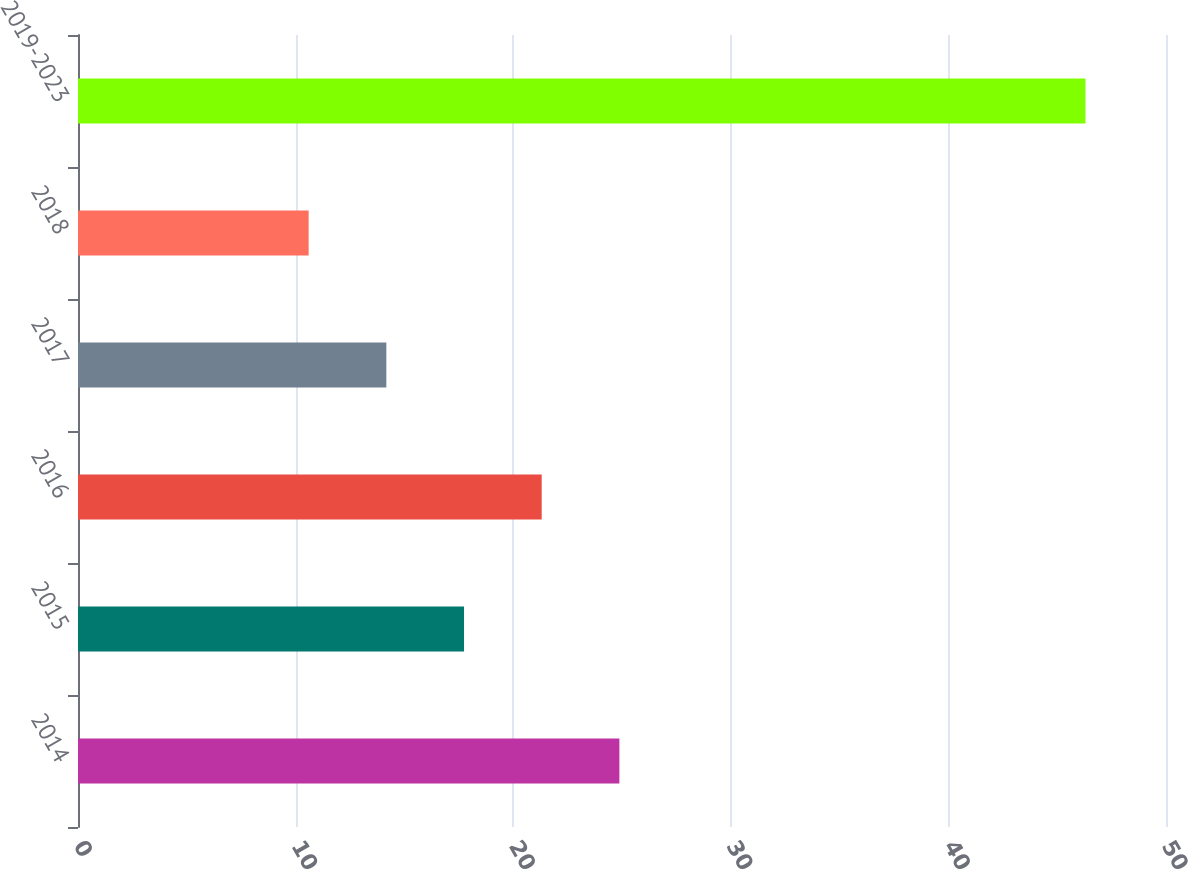<chart> <loc_0><loc_0><loc_500><loc_500><bar_chart><fcel>2014<fcel>2015<fcel>2016<fcel>2017<fcel>2018<fcel>2019-2023<nl><fcel>24.88<fcel>17.74<fcel>21.31<fcel>14.17<fcel>10.6<fcel>46.3<nl></chart> 